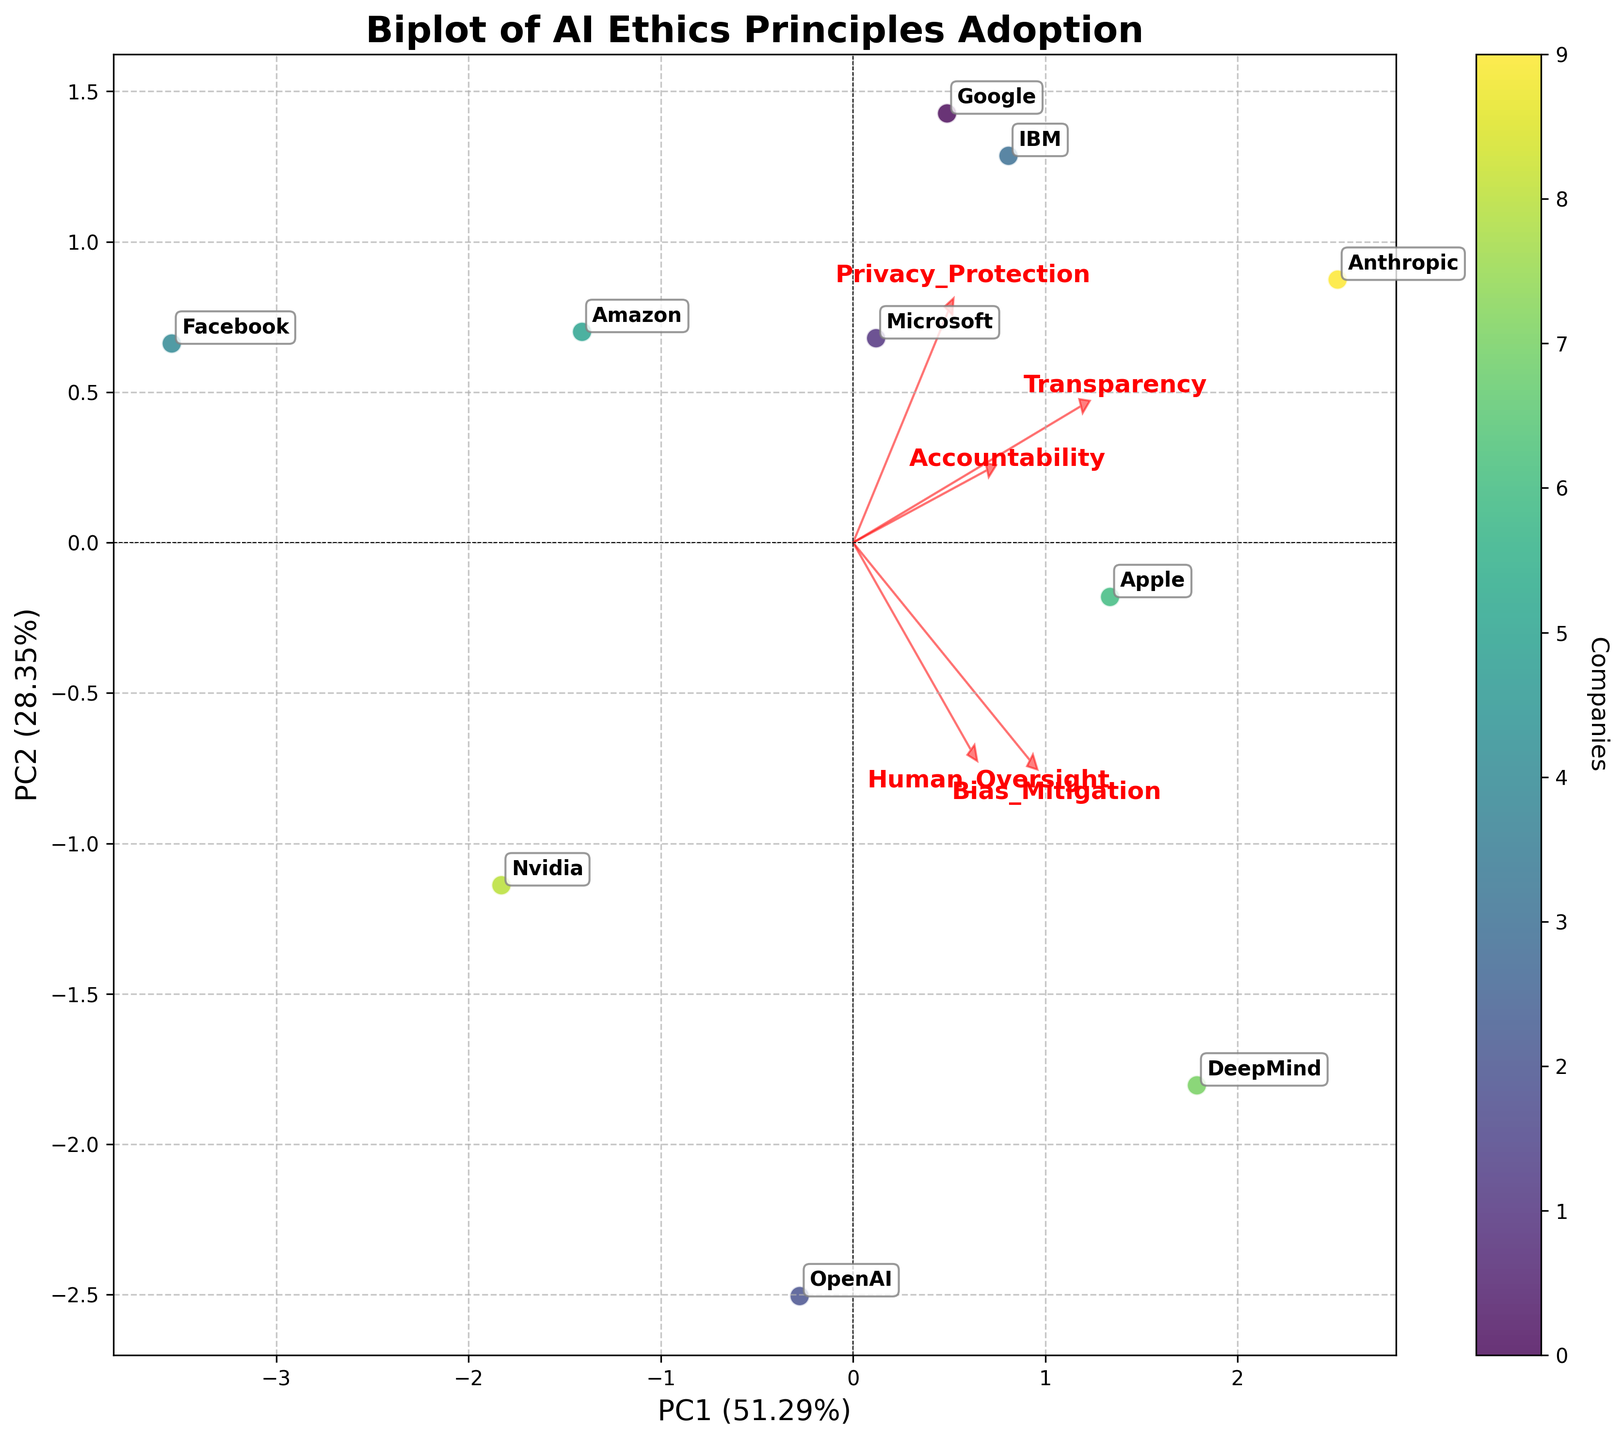What is the title of the figure? The title is usually displayed at the top of the figure. In this case, the title reads "Biplot of AI Ethics Principles Adoption".
Answer: Biplot of AI Ethics Principles Adoption Which company appears closest to the origin (0,0) on the biplot? Look at the plot and identify the data point that is nearest to the point where the x-axis and y-axis intersect (0,0).
Answer: Facebook Which variables are represented as the arrows extending from the origin? The variables are represented by the red arrows in the biplot. In this case, they are Transparency, Accountability, Bias_Mitigation, Privacy_Protection, and Human_Oversight.
Answer: Transparency, Accountability, Bias_Mitigation, Privacy_Protection, Human_Oversight What percentage of variance is explained by PC1 and PC2 combined? Check the labels of the x and y axes for the explained variance. Find the percentages and sum them up: PC1 (X-axis) and PC2 (Y-axis).
Answer: PC1 + PC2 Which company has the highest scores in both Transparency and Human_Oversight? Look at the positions of the companies along the loadings of Transparency and Human_Oversight arrows. Choose the company that is farthest in the direction indicated by both variables.
Answer: DeepMind Which two companies are positioned closest to each other on the biplot? Look at the overall placement of all points on the plot and identify the pair of points that are nearest to each other.
Answer: Google and DeepMind How does Amazon compare to Microsoft in terms of Privacy_Protection and Accountability? Assess the positions of Amazon and Microsoft relative to the arrows for Privacy_Protection and Accountability. Determine their alignment with these vectors.
Answer: Amazon is higher in Privacy_Protection, Microsoft is higher in Accountability Which variable seems to have the least influence on PC1? Evaluate the length and direction of the arrows. The variable with the smallest projection on PC1 is the one with the least influence.
Answer: Bias_Mitigation What can be inferred about Anthropic’s commitment to Privacy_Protection and Transparency? Locate Anthropic on the biplot and observe its position relevant to the Privacy_Protection and Transparency arrows.
Answer: High commitment in both Among OpenAI and Nvidia, which company demonstrates higher Bias_Mitigation? Compare the positions of OpenAI and Nvidia along the Bias_Mitigation vector. The company closer to the direction of the arrow has a higher score.
Answer: OpenAI 